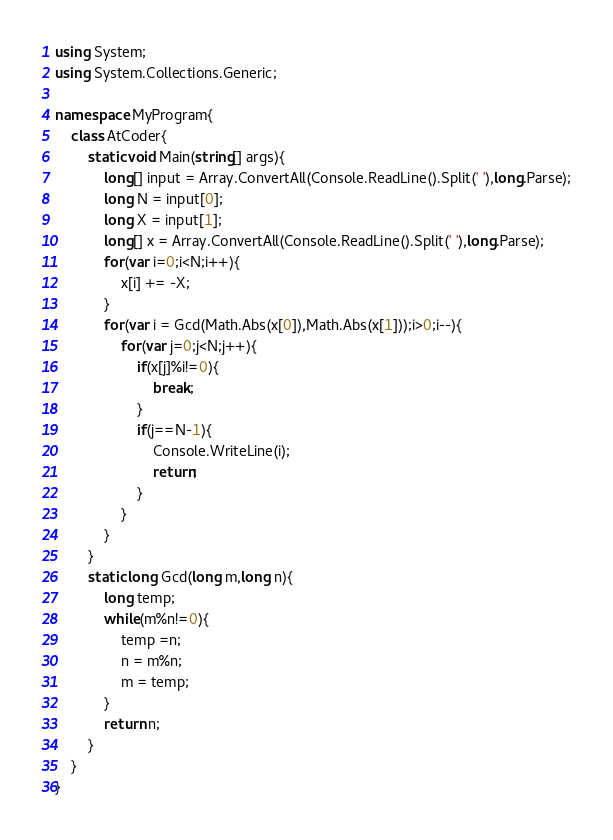<code> <loc_0><loc_0><loc_500><loc_500><_C#_>using System;
using System.Collections.Generic;

namespace MyProgram{
    class AtCoder{
        static void Main(string[] args){
            long[] input = Array.ConvertAll(Console.ReadLine().Split(' '),long.Parse);
            long N = input[0];
            long X = input[1];
            long[] x = Array.ConvertAll(Console.ReadLine().Split(' '),long.Parse);
            for(var i=0;i<N;i++){
                x[i] += -X;
            }
            for(var i = Gcd(Math.Abs(x[0]),Math.Abs(x[1]));i>0;i--){
                for(var j=0;j<N;j++){
                    if(x[j]%i!=0){
                        break;
                    }
                    if(j==N-1){
                        Console.WriteLine(i);
                        return;
                    }
                }
            }
        }
        static long Gcd(long m,long n){
            long temp;
            while(m%n!=0){
                temp =n;
                n = m%n;
                m = temp;
            }
            return n;
        }
    } 
}</code> 